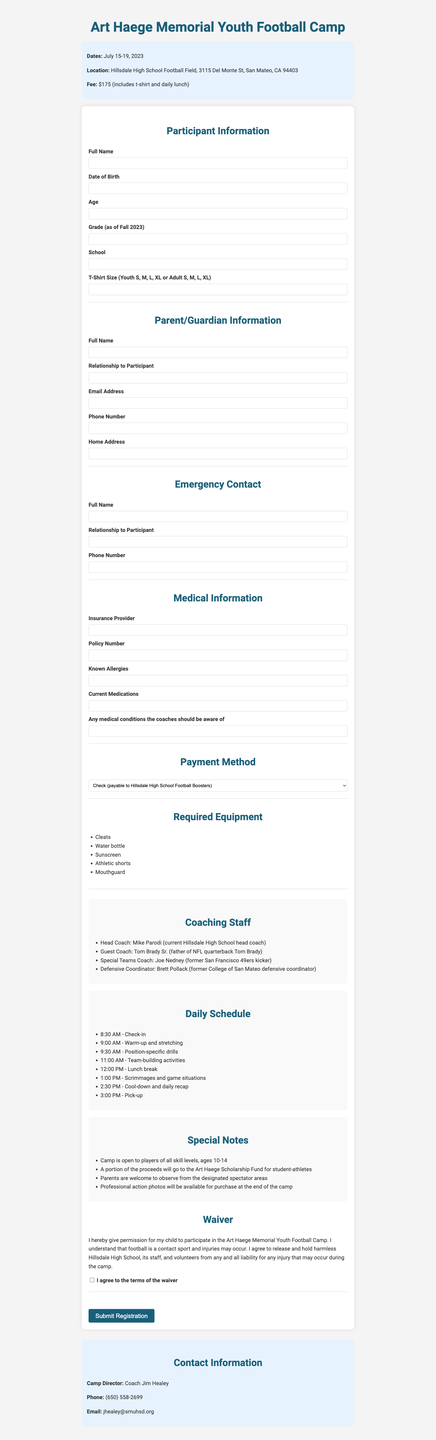What are the camp dates? The camp dates are listed under the camp details section of the document.
Answer: July 15-19, 2023 Who is the camp director? The camp director's name is mentioned in the contact information section of the document.
Answer: Coach Jim Healey What is the camp fee? The camp fee is specified in the camp information section for participants.
Answer: $175 What is required equipment for participants? Required equipment is listed in the relevant section of the document, detailing items to bring.
Answer: Cleats, Water bottle, Sunscreen, Athletic shorts, Mouthguard What is the age range for participants in the camp? The age range for participants is provided in the special notes section of the document.
Answer: 10-14 Which payment methods are accepted? Accepted payment methods are listed in a dedicated section in the document.
Answer: Check, Credit Card, Cash What is the insurance information needed? The medical information section specifies the insurance details required from participants.
Answer: Insurance Provider, Policy Number Who is the guest coach? The guest coach is mentioned in the coaching staff section of the document.
Answer: Tom Brady Sr What should participants wear? The document specifies required items in the equipment list, indicating necessary attire.
Answer: Athletic shorts, Cleats 